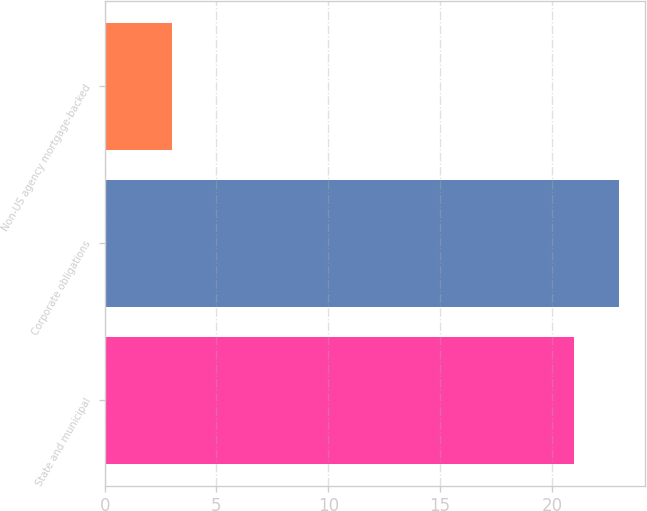<chart> <loc_0><loc_0><loc_500><loc_500><bar_chart><fcel>State and municipal<fcel>Corporate obligations<fcel>Non-US agency mortgage-backed<nl><fcel>21<fcel>23<fcel>3<nl></chart> 